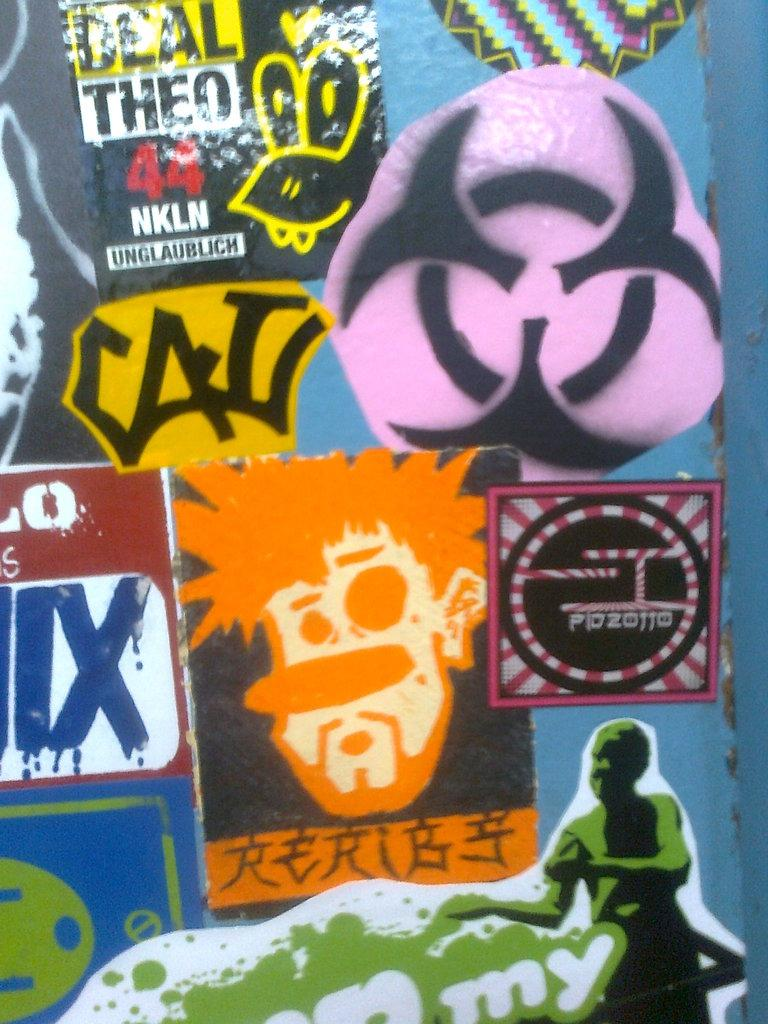<image>
Give a short and clear explanation of the subsequent image. a poster with CAU on it in grafiti fashion 